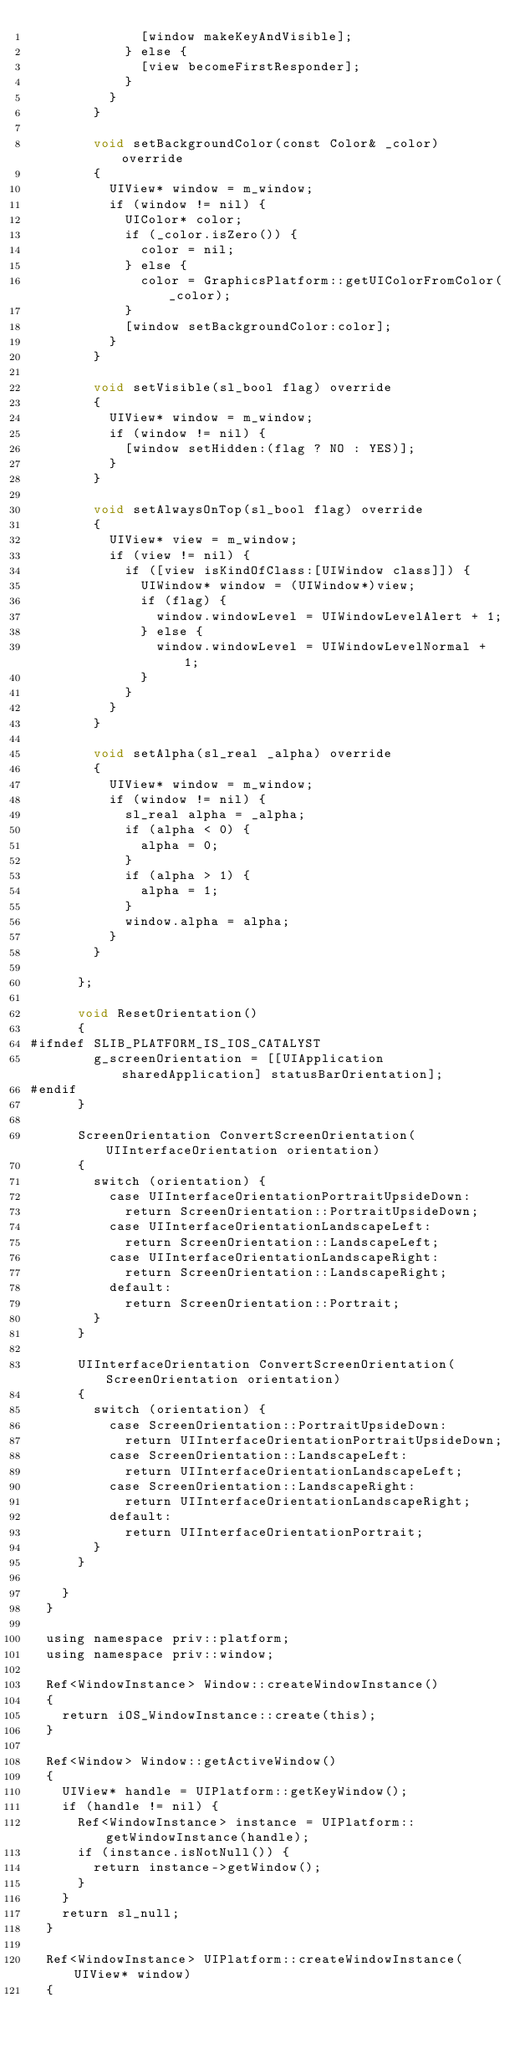Convert code to text. <code><loc_0><loc_0><loc_500><loc_500><_ObjectiveC_>							[window makeKeyAndVisible];
						} else {
							[view becomeFirstResponder];
						}
					}
				}
				
				void setBackgroundColor(const Color& _color) override
				{
					UIView* window = m_window;
					if (window != nil) {
						UIColor* color;
						if (_color.isZero()) {
							color = nil;
						} else {
							color = GraphicsPlatform::getUIColorFromColor(_color);
						}
						[window setBackgroundColor:color];
					}
				}
				
				void setVisible(sl_bool flag) override
				{
					UIView* window = m_window;
					if (window != nil) {
						[window setHidden:(flag ? NO : YES)];
					}
				}
				
				void setAlwaysOnTop(sl_bool flag) override
				{
					UIView* view = m_window;
					if (view != nil) {
						if ([view isKindOfClass:[UIWindow class]]) {
							UIWindow* window = (UIWindow*)view;
							if (flag) {
								window.windowLevel = UIWindowLevelAlert + 1;
							} else {
								window.windowLevel = UIWindowLevelNormal + 1;
							}
						}
					}
				}
				
				void setAlpha(sl_real _alpha) override
				{
					UIView* window = m_window;
					if (window != nil) {
						sl_real alpha = _alpha;
						if (alpha < 0) {
							alpha = 0;
						}
						if (alpha > 1) {
							alpha = 1;
						}
						window.alpha = alpha;
					}
				}
				
			};
			
			void ResetOrientation()
			{
#ifndef SLIB_PLATFORM_IS_IOS_CATALYST
				g_screenOrientation = [[UIApplication sharedApplication] statusBarOrientation];
#endif
			}
			
			ScreenOrientation ConvertScreenOrientation(UIInterfaceOrientation orientation)
			{
				switch (orientation) {
					case UIInterfaceOrientationPortraitUpsideDown:
						return ScreenOrientation::PortraitUpsideDown;
					case UIInterfaceOrientationLandscapeLeft:
						return ScreenOrientation::LandscapeLeft;
					case UIInterfaceOrientationLandscapeRight:
						return ScreenOrientation::LandscapeRight;
					default:
						return ScreenOrientation::Portrait;
				}
			}
			
			UIInterfaceOrientation ConvertScreenOrientation(ScreenOrientation orientation)
			{
				switch (orientation) {
					case ScreenOrientation::PortraitUpsideDown:
						return UIInterfaceOrientationPortraitUpsideDown;
					case ScreenOrientation::LandscapeLeft:
						return UIInterfaceOrientationLandscapeLeft;
					case ScreenOrientation::LandscapeRight:
						return UIInterfaceOrientationLandscapeRight;
					default:
						return UIInterfaceOrientationPortrait;
				}
			}
			
		}
	}

	using namespace priv::platform;
	using namespace priv::window;

	Ref<WindowInstance> Window::createWindowInstance()
	{
		return iOS_WindowInstance::create(this);
	}
	
	Ref<Window> Window::getActiveWindow()
	{
		UIView* handle = UIPlatform::getKeyWindow();
		if (handle != nil) {
			Ref<WindowInstance> instance = UIPlatform::getWindowInstance(handle);
			if (instance.isNotNull()) {
				return instance->getWindow();
			}
		}
		return sl_null;
	}
	
	Ref<WindowInstance> UIPlatform::createWindowInstance(UIView* window)
	{</code> 